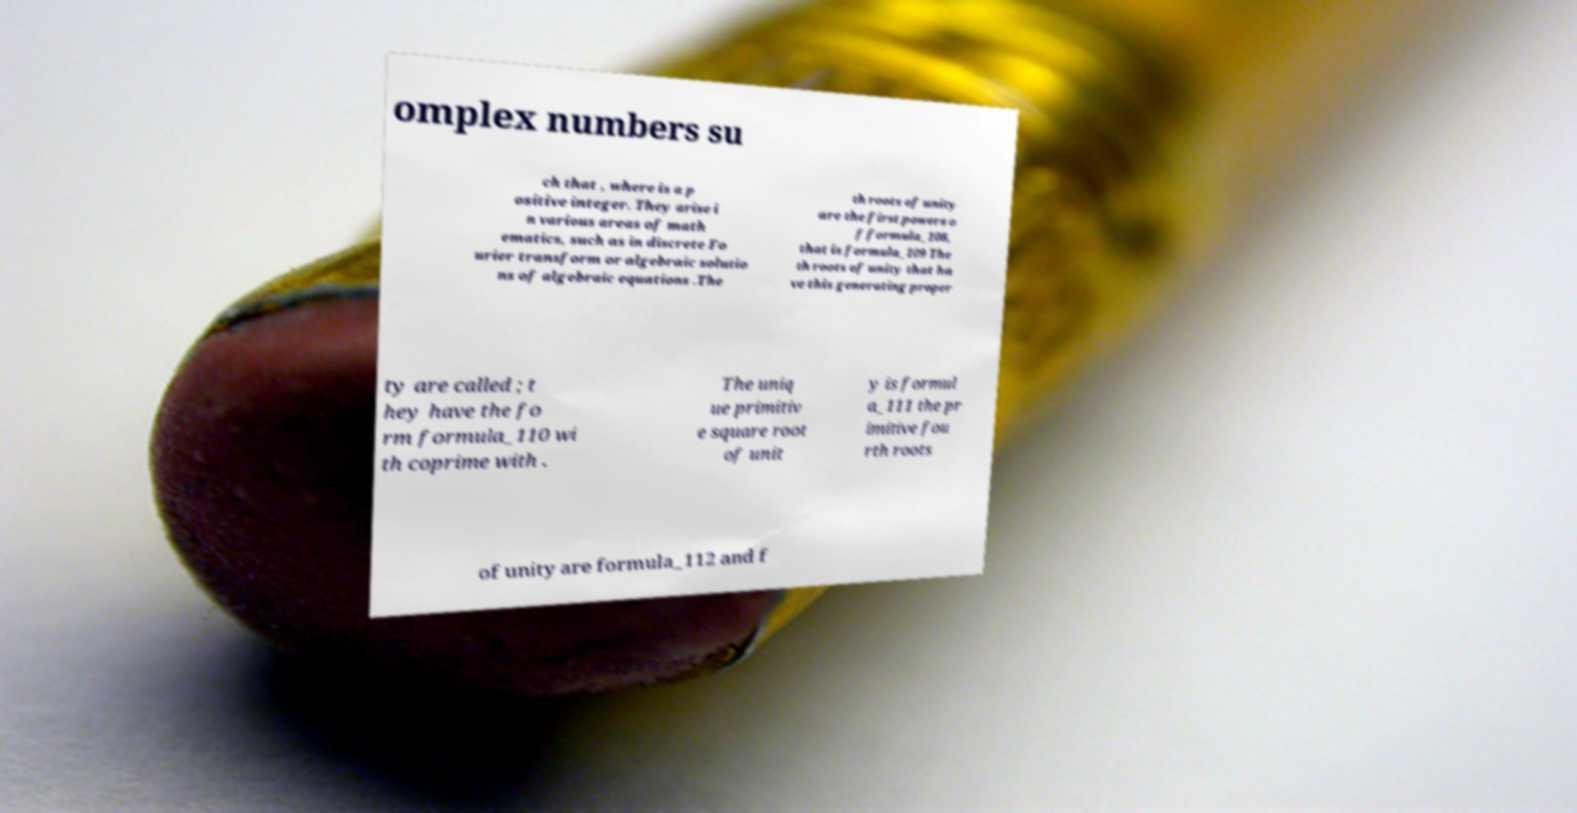I need the written content from this picture converted into text. Can you do that? omplex numbers su ch that , where is a p ositive integer. They arise i n various areas of math ematics, such as in discrete Fo urier transform or algebraic solutio ns of algebraic equations .The th roots of unity are the first powers o f formula_108, that is formula_109 The th roots of unity that ha ve this generating proper ty are called ; t hey have the fo rm formula_110 wi th coprime with . The uniq ue primitiv e square root of unit y is formul a_111 the pr imitive fou rth roots of unity are formula_112 and f 